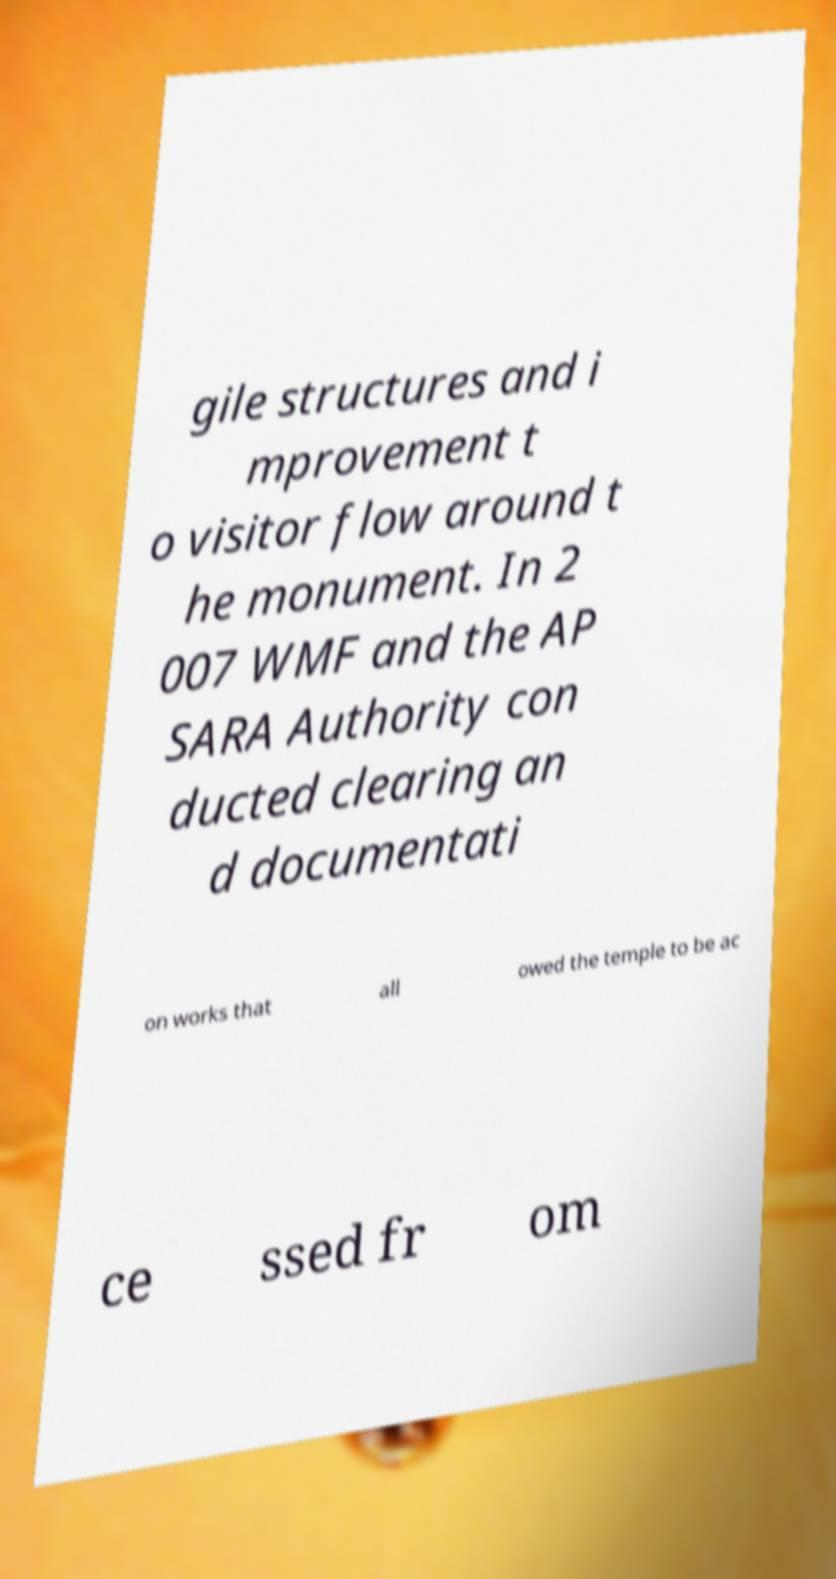What messages or text are displayed in this image? I need them in a readable, typed format. gile structures and i mprovement t o visitor flow around t he monument. In 2 007 WMF and the AP SARA Authority con ducted clearing an d documentati on works that all owed the temple to be ac ce ssed fr om 